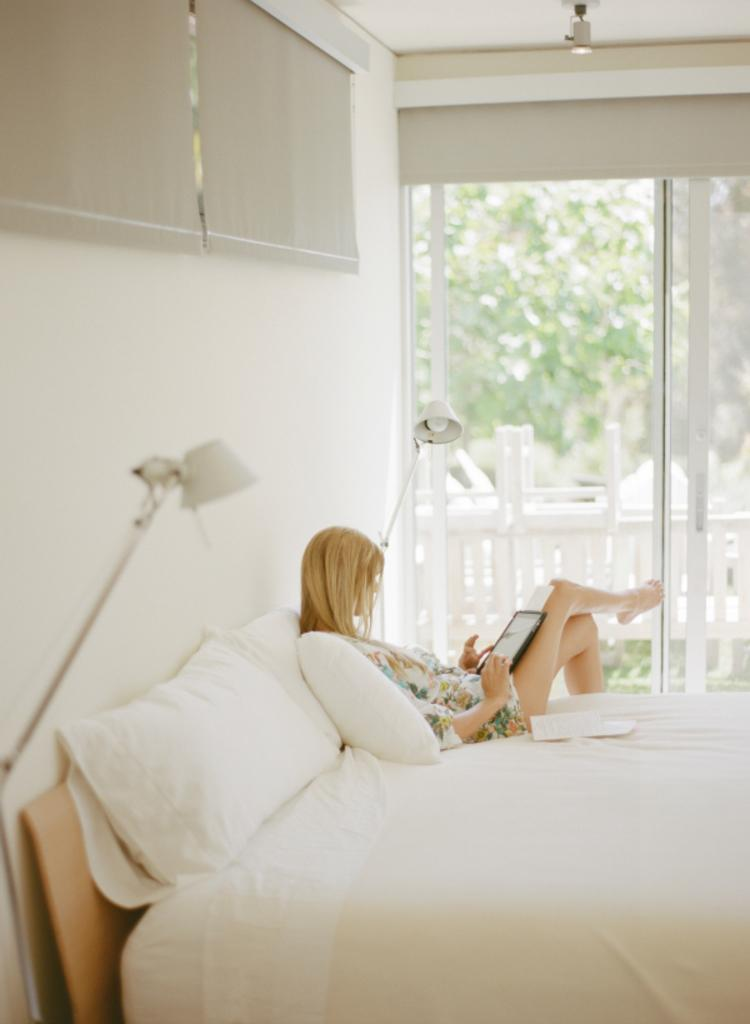What is the person in the image doing? The person is lying on the bed. Can you describe the location of the window in relation to the person? There is a window to the left of the person. What type of legal advice is the person seeking from the giants in the image? There are no giants or legal advice present in the image; it only features a person lying on a bed and a window. 